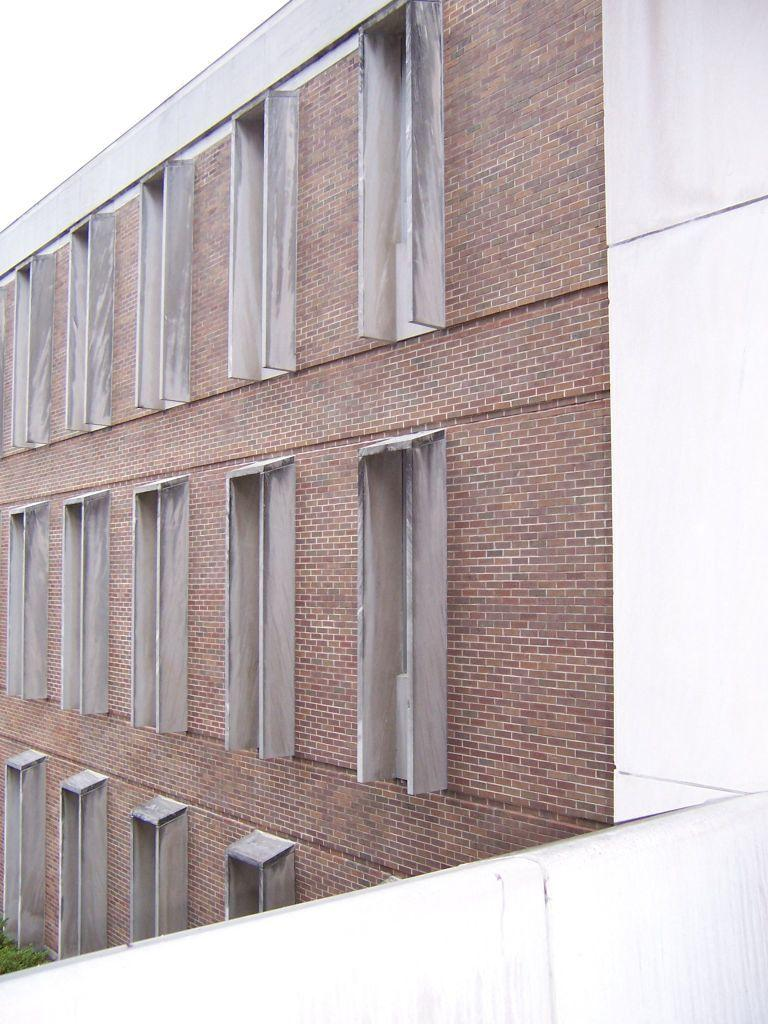What is the texture of the building in the image? The building has a brick texture. What architectural feature can be seen on the building? There are windows in the building. What color is the wall visible in the image? There is a white wall in the image. What type of argument is taking place in front of the building in the image? There is no argument present in the image; it only shows the building with a brick texture and windows, along with a white wall. What is the reaction of the celery to the building in the image? There is no celery present in the image, so it is not possible to determine its reaction to the building. 